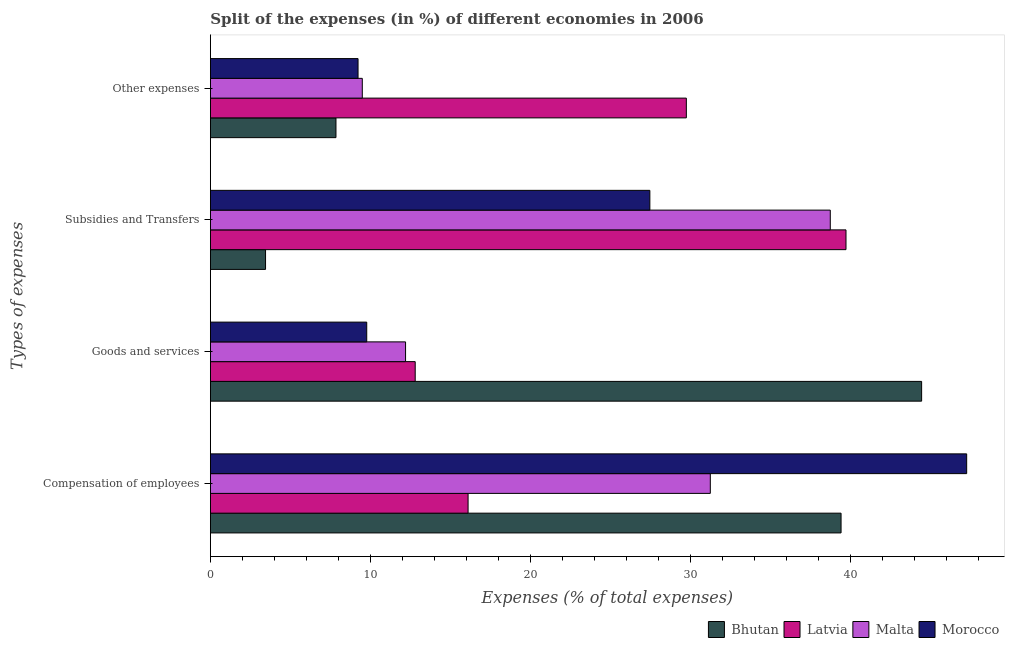How many groups of bars are there?
Your response must be concise. 4. Are the number of bars per tick equal to the number of legend labels?
Make the answer very short. Yes. Are the number of bars on each tick of the Y-axis equal?
Provide a short and direct response. Yes. How many bars are there on the 3rd tick from the top?
Offer a very short reply. 4. How many bars are there on the 3rd tick from the bottom?
Keep it short and to the point. 4. What is the label of the 3rd group of bars from the top?
Offer a terse response. Goods and services. What is the percentage of amount spent on other expenses in Malta?
Your answer should be very brief. 9.49. Across all countries, what is the maximum percentage of amount spent on compensation of employees?
Provide a succinct answer. 47.25. Across all countries, what is the minimum percentage of amount spent on subsidies?
Provide a succinct answer. 3.45. In which country was the percentage of amount spent on other expenses maximum?
Offer a very short reply. Latvia. In which country was the percentage of amount spent on subsidies minimum?
Give a very brief answer. Bhutan. What is the total percentage of amount spent on subsidies in the graph?
Keep it short and to the point. 109.34. What is the difference between the percentage of amount spent on other expenses in Malta and that in Bhutan?
Provide a succinct answer. 1.64. What is the difference between the percentage of amount spent on goods and services in Malta and the percentage of amount spent on compensation of employees in Morocco?
Give a very brief answer. -35.06. What is the average percentage of amount spent on subsidies per country?
Give a very brief answer. 27.34. What is the difference between the percentage of amount spent on compensation of employees and percentage of amount spent on subsidies in Morocco?
Ensure brevity in your answer.  19.79. In how many countries, is the percentage of amount spent on compensation of employees greater than 24 %?
Provide a short and direct response. 3. What is the ratio of the percentage of amount spent on other expenses in Morocco to that in Latvia?
Your answer should be compact. 0.31. Is the percentage of amount spent on subsidies in Bhutan less than that in Morocco?
Make the answer very short. Yes. Is the difference between the percentage of amount spent on goods and services in Bhutan and Malta greater than the difference between the percentage of amount spent on subsidies in Bhutan and Malta?
Ensure brevity in your answer.  Yes. What is the difference between the highest and the second highest percentage of amount spent on compensation of employees?
Make the answer very short. 7.85. What is the difference between the highest and the lowest percentage of amount spent on subsidies?
Ensure brevity in your answer.  36.26. Is it the case that in every country, the sum of the percentage of amount spent on subsidies and percentage of amount spent on goods and services is greater than the sum of percentage of amount spent on other expenses and percentage of amount spent on compensation of employees?
Keep it short and to the point. No. What does the 3rd bar from the top in Subsidies and Transfers represents?
Your response must be concise. Latvia. What does the 4th bar from the bottom in Goods and services represents?
Your answer should be compact. Morocco. Is it the case that in every country, the sum of the percentage of amount spent on compensation of employees and percentage of amount spent on goods and services is greater than the percentage of amount spent on subsidies?
Give a very brief answer. No. How many countries are there in the graph?
Offer a terse response. 4. What is the difference between two consecutive major ticks on the X-axis?
Provide a succinct answer. 10. Are the values on the major ticks of X-axis written in scientific E-notation?
Your response must be concise. No. How are the legend labels stacked?
Provide a succinct answer. Horizontal. What is the title of the graph?
Offer a terse response. Split of the expenses (in %) of different economies in 2006. What is the label or title of the X-axis?
Make the answer very short. Expenses (% of total expenses). What is the label or title of the Y-axis?
Provide a succinct answer. Types of expenses. What is the Expenses (% of total expenses) of Bhutan in Compensation of employees?
Provide a succinct answer. 39.4. What is the Expenses (% of total expenses) of Latvia in Compensation of employees?
Keep it short and to the point. 16.1. What is the Expenses (% of total expenses) in Malta in Compensation of employees?
Give a very brief answer. 31.23. What is the Expenses (% of total expenses) in Morocco in Compensation of employees?
Offer a terse response. 47.25. What is the Expenses (% of total expenses) of Bhutan in Goods and services?
Give a very brief answer. 44.44. What is the Expenses (% of total expenses) of Latvia in Goods and services?
Your answer should be very brief. 12.8. What is the Expenses (% of total expenses) of Malta in Goods and services?
Your answer should be compact. 12.19. What is the Expenses (% of total expenses) in Morocco in Goods and services?
Offer a terse response. 9.77. What is the Expenses (% of total expenses) in Bhutan in Subsidies and Transfers?
Your answer should be very brief. 3.45. What is the Expenses (% of total expenses) in Latvia in Subsidies and Transfers?
Ensure brevity in your answer.  39.71. What is the Expenses (% of total expenses) of Malta in Subsidies and Transfers?
Offer a terse response. 38.73. What is the Expenses (% of total expenses) of Morocco in Subsidies and Transfers?
Ensure brevity in your answer.  27.46. What is the Expenses (% of total expenses) in Bhutan in Other expenses?
Ensure brevity in your answer.  7.85. What is the Expenses (% of total expenses) in Latvia in Other expenses?
Provide a succinct answer. 29.74. What is the Expenses (% of total expenses) of Malta in Other expenses?
Provide a succinct answer. 9.49. What is the Expenses (% of total expenses) of Morocco in Other expenses?
Provide a succinct answer. 9.23. Across all Types of expenses, what is the maximum Expenses (% of total expenses) of Bhutan?
Your answer should be compact. 44.44. Across all Types of expenses, what is the maximum Expenses (% of total expenses) in Latvia?
Your answer should be very brief. 39.71. Across all Types of expenses, what is the maximum Expenses (% of total expenses) of Malta?
Your response must be concise. 38.73. Across all Types of expenses, what is the maximum Expenses (% of total expenses) in Morocco?
Offer a very short reply. 47.25. Across all Types of expenses, what is the minimum Expenses (% of total expenses) of Bhutan?
Give a very brief answer. 3.45. Across all Types of expenses, what is the minimum Expenses (% of total expenses) of Latvia?
Your answer should be compact. 12.8. Across all Types of expenses, what is the minimum Expenses (% of total expenses) in Malta?
Your answer should be compact. 9.49. Across all Types of expenses, what is the minimum Expenses (% of total expenses) in Morocco?
Offer a terse response. 9.23. What is the total Expenses (% of total expenses) of Bhutan in the graph?
Provide a short and direct response. 95.13. What is the total Expenses (% of total expenses) of Latvia in the graph?
Make the answer very short. 98.34. What is the total Expenses (% of total expenses) in Malta in the graph?
Your answer should be compact. 91.65. What is the total Expenses (% of total expenses) in Morocco in the graph?
Ensure brevity in your answer.  93.7. What is the difference between the Expenses (% of total expenses) in Bhutan in Compensation of employees and that in Goods and services?
Provide a short and direct response. -5.03. What is the difference between the Expenses (% of total expenses) of Latvia in Compensation of employees and that in Goods and services?
Ensure brevity in your answer.  3.3. What is the difference between the Expenses (% of total expenses) of Malta in Compensation of employees and that in Goods and services?
Keep it short and to the point. 19.04. What is the difference between the Expenses (% of total expenses) in Morocco in Compensation of employees and that in Goods and services?
Provide a short and direct response. 37.48. What is the difference between the Expenses (% of total expenses) of Bhutan in Compensation of employees and that in Subsidies and Transfers?
Provide a short and direct response. 35.96. What is the difference between the Expenses (% of total expenses) of Latvia in Compensation of employees and that in Subsidies and Transfers?
Your response must be concise. -23.61. What is the difference between the Expenses (% of total expenses) in Malta in Compensation of employees and that in Subsidies and Transfers?
Your answer should be compact. -7.5. What is the difference between the Expenses (% of total expenses) in Morocco in Compensation of employees and that in Subsidies and Transfers?
Your response must be concise. 19.79. What is the difference between the Expenses (% of total expenses) in Bhutan in Compensation of employees and that in Other expenses?
Give a very brief answer. 31.56. What is the difference between the Expenses (% of total expenses) in Latvia in Compensation of employees and that in Other expenses?
Keep it short and to the point. -13.64. What is the difference between the Expenses (% of total expenses) in Malta in Compensation of employees and that in Other expenses?
Your response must be concise. 21.74. What is the difference between the Expenses (% of total expenses) of Morocco in Compensation of employees and that in Other expenses?
Give a very brief answer. 38.02. What is the difference between the Expenses (% of total expenses) of Bhutan in Goods and services and that in Subsidies and Transfers?
Offer a very short reply. 40.99. What is the difference between the Expenses (% of total expenses) in Latvia in Goods and services and that in Subsidies and Transfers?
Keep it short and to the point. -26.91. What is the difference between the Expenses (% of total expenses) of Malta in Goods and services and that in Subsidies and Transfers?
Your answer should be compact. -26.54. What is the difference between the Expenses (% of total expenses) of Morocco in Goods and services and that in Subsidies and Transfers?
Offer a terse response. -17.69. What is the difference between the Expenses (% of total expenses) in Bhutan in Goods and services and that in Other expenses?
Keep it short and to the point. 36.59. What is the difference between the Expenses (% of total expenses) in Latvia in Goods and services and that in Other expenses?
Your answer should be very brief. -16.94. What is the difference between the Expenses (% of total expenses) in Malta in Goods and services and that in Other expenses?
Your answer should be very brief. 2.7. What is the difference between the Expenses (% of total expenses) in Morocco in Goods and services and that in Other expenses?
Offer a very short reply. 0.54. What is the difference between the Expenses (% of total expenses) in Bhutan in Subsidies and Transfers and that in Other expenses?
Make the answer very short. -4.4. What is the difference between the Expenses (% of total expenses) in Latvia in Subsidies and Transfers and that in Other expenses?
Your answer should be compact. 9.97. What is the difference between the Expenses (% of total expenses) in Malta in Subsidies and Transfers and that in Other expenses?
Keep it short and to the point. 29.24. What is the difference between the Expenses (% of total expenses) in Morocco in Subsidies and Transfers and that in Other expenses?
Your answer should be compact. 18.23. What is the difference between the Expenses (% of total expenses) of Bhutan in Compensation of employees and the Expenses (% of total expenses) of Latvia in Goods and services?
Your answer should be compact. 26.61. What is the difference between the Expenses (% of total expenses) of Bhutan in Compensation of employees and the Expenses (% of total expenses) of Malta in Goods and services?
Ensure brevity in your answer.  27.21. What is the difference between the Expenses (% of total expenses) in Bhutan in Compensation of employees and the Expenses (% of total expenses) in Morocco in Goods and services?
Give a very brief answer. 29.63. What is the difference between the Expenses (% of total expenses) of Latvia in Compensation of employees and the Expenses (% of total expenses) of Malta in Goods and services?
Your response must be concise. 3.91. What is the difference between the Expenses (% of total expenses) of Latvia in Compensation of employees and the Expenses (% of total expenses) of Morocco in Goods and services?
Offer a terse response. 6.33. What is the difference between the Expenses (% of total expenses) in Malta in Compensation of employees and the Expenses (% of total expenses) in Morocco in Goods and services?
Offer a terse response. 21.47. What is the difference between the Expenses (% of total expenses) in Bhutan in Compensation of employees and the Expenses (% of total expenses) in Latvia in Subsidies and Transfers?
Provide a succinct answer. -0.31. What is the difference between the Expenses (% of total expenses) in Bhutan in Compensation of employees and the Expenses (% of total expenses) in Malta in Subsidies and Transfers?
Offer a terse response. 0.67. What is the difference between the Expenses (% of total expenses) in Bhutan in Compensation of employees and the Expenses (% of total expenses) in Morocco in Subsidies and Transfers?
Your answer should be very brief. 11.95. What is the difference between the Expenses (% of total expenses) of Latvia in Compensation of employees and the Expenses (% of total expenses) of Malta in Subsidies and Transfers?
Make the answer very short. -22.63. What is the difference between the Expenses (% of total expenses) in Latvia in Compensation of employees and the Expenses (% of total expenses) in Morocco in Subsidies and Transfers?
Give a very brief answer. -11.36. What is the difference between the Expenses (% of total expenses) in Malta in Compensation of employees and the Expenses (% of total expenses) in Morocco in Subsidies and Transfers?
Offer a terse response. 3.78. What is the difference between the Expenses (% of total expenses) in Bhutan in Compensation of employees and the Expenses (% of total expenses) in Latvia in Other expenses?
Offer a terse response. 9.67. What is the difference between the Expenses (% of total expenses) in Bhutan in Compensation of employees and the Expenses (% of total expenses) in Malta in Other expenses?
Provide a short and direct response. 29.91. What is the difference between the Expenses (% of total expenses) of Bhutan in Compensation of employees and the Expenses (% of total expenses) of Morocco in Other expenses?
Give a very brief answer. 30.18. What is the difference between the Expenses (% of total expenses) of Latvia in Compensation of employees and the Expenses (% of total expenses) of Malta in Other expenses?
Offer a very short reply. 6.61. What is the difference between the Expenses (% of total expenses) in Latvia in Compensation of employees and the Expenses (% of total expenses) in Morocco in Other expenses?
Keep it short and to the point. 6.87. What is the difference between the Expenses (% of total expenses) of Malta in Compensation of employees and the Expenses (% of total expenses) of Morocco in Other expenses?
Ensure brevity in your answer.  22.01. What is the difference between the Expenses (% of total expenses) in Bhutan in Goods and services and the Expenses (% of total expenses) in Latvia in Subsidies and Transfers?
Give a very brief answer. 4.73. What is the difference between the Expenses (% of total expenses) of Bhutan in Goods and services and the Expenses (% of total expenses) of Malta in Subsidies and Transfers?
Offer a terse response. 5.71. What is the difference between the Expenses (% of total expenses) in Bhutan in Goods and services and the Expenses (% of total expenses) in Morocco in Subsidies and Transfers?
Provide a short and direct response. 16.98. What is the difference between the Expenses (% of total expenses) in Latvia in Goods and services and the Expenses (% of total expenses) in Malta in Subsidies and Transfers?
Make the answer very short. -25.93. What is the difference between the Expenses (% of total expenses) in Latvia in Goods and services and the Expenses (% of total expenses) in Morocco in Subsidies and Transfers?
Keep it short and to the point. -14.66. What is the difference between the Expenses (% of total expenses) in Malta in Goods and services and the Expenses (% of total expenses) in Morocco in Subsidies and Transfers?
Your response must be concise. -15.26. What is the difference between the Expenses (% of total expenses) in Bhutan in Goods and services and the Expenses (% of total expenses) in Latvia in Other expenses?
Your answer should be very brief. 14.7. What is the difference between the Expenses (% of total expenses) of Bhutan in Goods and services and the Expenses (% of total expenses) of Malta in Other expenses?
Offer a very short reply. 34.95. What is the difference between the Expenses (% of total expenses) of Bhutan in Goods and services and the Expenses (% of total expenses) of Morocco in Other expenses?
Your answer should be very brief. 35.21. What is the difference between the Expenses (% of total expenses) in Latvia in Goods and services and the Expenses (% of total expenses) in Malta in Other expenses?
Provide a short and direct response. 3.31. What is the difference between the Expenses (% of total expenses) in Latvia in Goods and services and the Expenses (% of total expenses) in Morocco in Other expenses?
Make the answer very short. 3.57. What is the difference between the Expenses (% of total expenses) of Malta in Goods and services and the Expenses (% of total expenses) of Morocco in Other expenses?
Keep it short and to the point. 2.97. What is the difference between the Expenses (% of total expenses) in Bhutan in Subsidies and Transfers and the Expenses (% of total expenses) in Latvia in Other expenses?
Your answer should be very brief. -26.29. What is the difference between the Expenses (% of total expenses) of Bhutan in Subsidies and Transfers and the Expenses (% of total expenses) of Malta in Other expenses?
Your answer should be very brief. -6.04. What is the difference between the Expenses (% of total expenses) in Bhutan in Subsidies and Transfers and the Expenses (% of total expenses) in Morocco in Other expenses?
Offer a very short reply. -5.78. What is the difference between the Expenses (% of total expenses) of Latvia in Subsidies and Transfers and the Expenses (% of total expenses) of Malta in Other expenses?
Make the answer very short. 30.22. What is the difference between the Expenses (% of total expenses) of Latvia in Subsidies and Transfers and the Expenses (% of total expenses) of Morocco in Other expenses?
Offer a terse response. 30.49. What is the difference between the Expenses (% of total expenses) of Malta in Subsidies and Transfers and the Expenses (% of total expenses) of Morocco in Other expenses?
Provide a short and direct response. 29.5. What is the average Expenses (% of total expenses) of Bhutan per Types of expenses?
Keep it short and to the point. 23.78. What is the average Expenses (% of total expenses) in Latvia per Types of expenses?
Offer a very short reply. 24.59. What is the average Expenses (% of total expenses) of Malta per Types of expenses?
Provide a succinct answer. 22.91. What is the average Expenses (% of total expenses) of Morocco per Types of expenses?
Offer a very short reply. 23.43. What is the difference between the Expenses (% of total expenses) of Bhutan and Expenses (% of total expenses) of Latvia in Compensation of employees?
Give a very brief answer. 23.3. What is the difference between the Expenses (% of total expenses) in Bhutan and Expenses (% of total expenses) in Malta in Compensation of employees?
Give a very brief answer. 8.17. What is the difference between the Expenses (% of total expenses) of Bhutan and Expenses (% of total expenses) of Morocco in Compensation of employees?
Your answer should be compact. -7.85. What is the difference between the Expenses (% of total expenses) of Latvia and Expenses (% of total expenses) of Malta in Compensation of employees?
Your response must be concise. -15.13. What is the difference between the Expenses (% of total expenses) in Latvia and Expenses (% of total expenses) in Morocco in Compensation of employees?
Give a very brief answer. -31.15. What is the difference between the Expenses (% of total expenses) of Malta and Expenses (% of total expenses) of Morocco in Compensation of employees?
Your answer should be compact. -16.02. What is the difference between the Expenses (% of total expenses) in Bhutan and Expenses (% of total expenses) in Latvia in Goods and services?
Provide a short and direct response. 31.64. What is the difference between the Expenses (% of total expenses) of Bhutan and Expenses (% of total expenses) of Malta in Goods and services?
Offer a terse response. 32.24. What is the difference between the Expenses (% of total expenses) in Bhutan and Expenses (% of total expenses) in Morocco in Goods and services?
Offer a very short reply. 34.67. What is the difference between the Expenses (% of total expenses) of Latvia and Expenses (% of total expenses) of Malta in Goods and services?
Your response must be concise. 0.6. What is the difference between the Expenses (% of total expenses) in Latvia and Expenses (% of total expenses) in Morocco in Goods and services?
Your answer should be very brief. 3.03. What is the difference between the Expenses (% of total expenses) in Malta and Expenses (% of total expenses) in Morocco in Goods and services?
Offer a very short reply. 2.43. What is the difference between the Expenses (% of total expenses) of Bhutan and Expenses (% of total expenses) of Latvia in Subsidies and Transfers?
Your response must be concise. -36.26. What is the difference between the Expenses (% of total expenses) of Bhutan and Expenses (% of total expenses) of Malta in Subsidies and Transfers?
Your answer should be very brief. -35.28. What is the difference between the Expenses (% of total expenses) of Bhutan and Expenses (% of total expenses) of Morocco in Subsidies and Transfers?
Provide a short and direct response. -24.01. What is the difference between the Expenses (% of total expenses) of Latvia and Expenses (% of total expenses) of Malta in Subsidies and Transfers?
Give a very brief answer. 0.98. What is the difference between the Expenses (% of total expenses) in Latvia and Expenses (% of total expenses) in Morocco in Subsidies and Transfers?
Your answer should be very brief. 12.25. What is the difference between the Expenses (% of total expenses) in Malta and Expenses (% of total expenses) in Morocco in Subsidies and Transfers?
Your answer should be compact. 11.27. What is the difference between the Expenses (% of total expenses) of Bhutan and Expenses (% of total expenses) of Latvia in Other expenses?
Ensure brevity in your answer.  -21.89. What is the difference between the Expenses (% of total expenses) in Bhutan and Expenses (% of total expenses) in Malta in Other expenses?
Offer a very short reply. -1.64. What is the difference between the Expenses (% of total expenses) in Bhutan and Expenses (% of total expenses) in Morocco in Other expenses?
Ensure brevity in your answer.  -1.38. What is the difference between the Expenses (% of total expenses) of Latvia and Expenses (% of total expenses) of Malta in Other expenses?
Offer a very short reply. 20.25. What is the difference between the Expenses (% of total expenses) in Latvia and Expenses (% of total expenses) in Morocco in Other expenses?
Your answer should be very brief. 20.51. What is the difference between the Expenses (% of total expenses) in Malta and Expenses (% of total expenses) in Morocco in Other expenses?
Make the answer very short. 0.26. What is the ratio of the Expenses (% of total expenses) in Bhutan in Compensation of employees to that in Goods and services?
Provide a succinct answer. 0.89. What is the ratio of the Expenses (% of total expenses) in Latvia in Compensation of employees to that in Goods and services?
Provide a succinct answer. 1.26. What is the ratio of the Expenses (% of total expenses) in Malta in Compensation of employees to that in Goods and services?
Your answer should be compact. 2.56. What is the ratio of the Expenses (% of total expenses) of Morocco in Compensation of employees to that in Goods and services?
Offer a terse response. 4.84. What is the ratio of the Expenses (% of total expenses) of Bhutan in Compensation of employees to that in Subsidies and Transfers?
Ensure brevity in your answer.  11.43. What is the ratio of the Expenses (% of total expenses) of Latvia in Compensation of employees to that in Subsidies and Transfers?
Provide a short and direct response. 0.41. What is the ratio of the Expenses (% of total expenses) of Malta in Compensation of employees to that in Subsidies and Transfers?
Offer a very short reply. 0.81. What is the ratio of the Expenses (% of total expenses) in Morocco in Compensation of employees to that in Subsidies and Transfers?
Your answer should be compact. 1.72. What is the ratio of the Expenses (% of total expenses) of Bhutan in Compensation of employees to that in Other expenses?
Ensure brevity in your answer.  5.02. What is the ratio of the Expenses (% of total expenses) in Latvia in Compensation of employees to that in Other expenses?
Your answer should be compact. 0.54. What is the ratio of the Expenses (% of total expenses) of Malta in Compensation of employees to that in Other expenses?
Offer a very short reply. 3.29. What is the ratio of the Expenses (% of total expenses) of Morocco in Compensation of employees to that in Other expenses?
Provide a short and direct response. 5.12. What is the ratio of the Expenses (% of total expenses) in Bhutan in Goods and services to that in Subsidies and Transfers?
Provide a succinct answer. 12.89. What is the ratio of the Expenses (% of total expenses) in Latvia in Goods and services to that in Subsidies and Transfers?
Keep it short and to the point. 0.32. What is the ratio of the Expenses (% of total expenses) of Malta in Goods and services to that in Subsidies and Transfers?
Your answer should be very brief. 0.31. What is the ratio of the Expenses (% of total expenses) of Morocco in Goods and services to that in Subsidies and Transfers?
Provide a short and direct response. 0.36. What is the ratio of the Expenses (% of total expenses) of Bhutan in Goods and services to that in Other expenses?
Make the answer very short. 5.66. What is the ratio of the Expenses (% of total expenses) in Latvia in Goods and services to that in Other expenses?
Ensure brevity in your answer.  0.43. What is the ratio of the Expenses (% of total expenses) in Malta in Goods and services to that in Other expenses?
Your response must be concise. 1.28. What is the ratio of the Expenses (% of total expenses) of Morocco in Goods and services to that in Other expenses?
Your answer should be very brief. 1.06. What is the ratio of the Expenses (% of total expenses) in Bhutan in Subsidies and Transfers to that in Other expenses?
Provide a short and direct response. 0.44. What is the ratio of the Expenses (% of total expenses) of Latvia in Subsidies and Transfers to that in Other expenses?
Your answer should be very brief. 1.34. What is the ratio of the Expenses (% of total expenses) in Malta in Subsidies and Transfers to that in Other expenses?
Your answer should be compact. 4.08. What is the ratio of the Expenses (% of total expenses) in Morocco in Subsidies and Transfers to that in Other expenses?
Your response must be concise. 2.98. What is the difference between the highest and the second highest Expenses (% of total expenses) in Bhutan?
Provide a succinct answer. 5.03. What is the difference between the highest and the second highest Expenses (% of total expenses) in Latvia?
Keep it short and to the point. 9.97. What is the difference between the highest and the second highest Expenses (% of total expenses) of Malta?
Your response must be concise. 7.5. What is the difference between the highest and the second highest Expenses (% of total expenses) of Morocco?
Keep it short and to the point. 19.79. What is the difference between the highest and the lowest Expenses (% of total expenses) of Bhutan?
Provide a succinct answer. 40.99. What is the difference between the highest and the lowest Expenses (% of total expenses) in Latvia?
Your answer should be very brief. 26.91. What is the difference between the highest and the lowest Expenses (% of total expenses) in Malta?
Make the answer very short. 29.24. What is the difference between the highest and the lowest Expenses (% of total expenses) in Morocco?
Your answer should be compact. 38.02. 